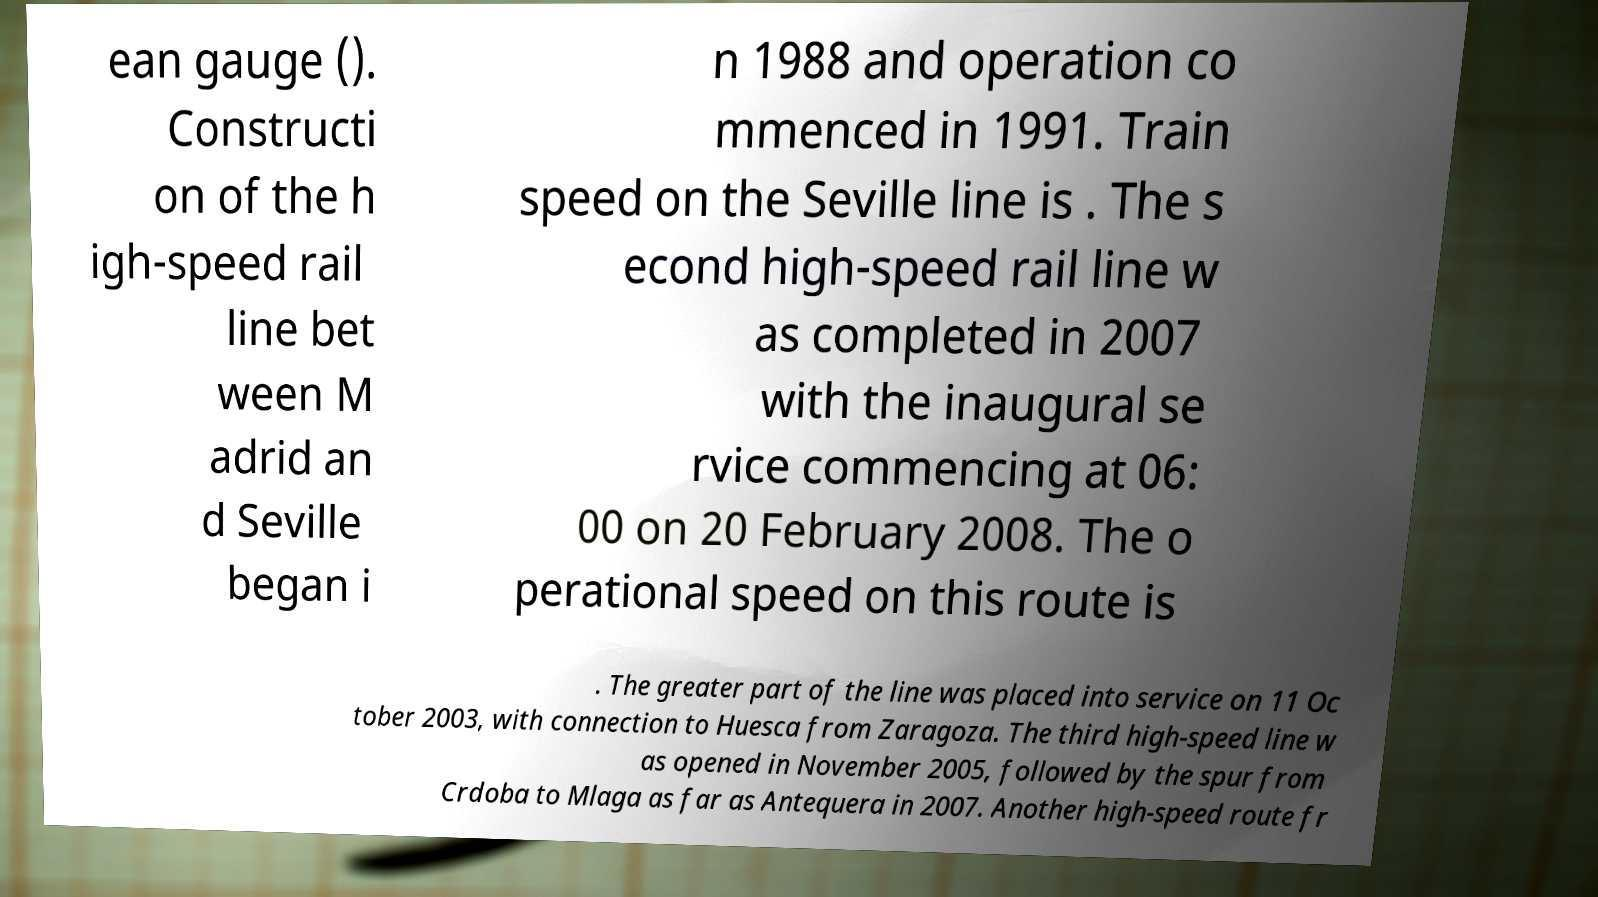Please read and relay the text visible in this image. What does it say? ean gauge (). Constructi on of the h igh-speed rail line bet ween M adrid an d Seville began i n 1988 and operation co mmenced in 1991. Train speed on the Seville line is . The s econd high-speed rail line w as completed in 2007 with the inaugural se rvice commencing at 06: 00 on 20 February 2008. The o perational speed on this route is . The greater part of the line was placed into service on 11 Oc tober 2003, with connection to Huesca from Zaragoza. The third high-speed line w as opened in November 2005, followed by the spur from Crdoba to Mlaga as far as Antequera in 2007. Another high-speed route fr 